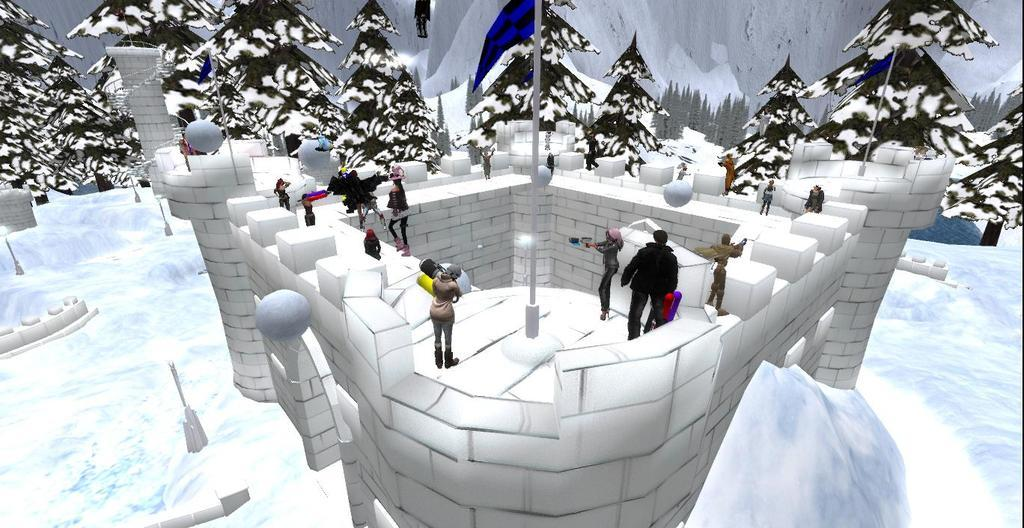How many people are present in the image? There are people in the image, but the exact number is not specified. What structures can be seen in the image? There are poles, pillars, and a fort in the image. What type of vegetation is present in the image? There are trees in the image. What is the condition of the ground in the image? The ground is covered with snow in the image. Can you describe any other objects in the image? There are some objects in the image, but their specific nature is not mentioned. What is the level of pollution in the town depicted in the image? There is no town depicted in the image, and therefore no pollution level can be determined. 